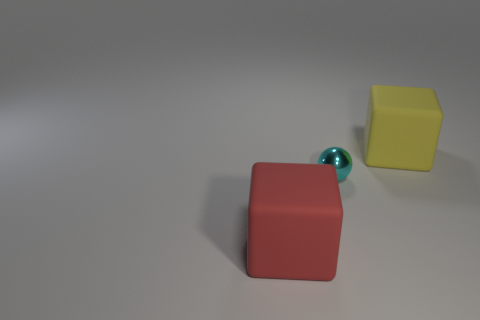Add 1 yellow cubes. How many objects exist? 4 Subtract all spheres. How many objects are left? 2 Add 2 small matte cubes. How many small matte cubes exist? 2 Subtract 0 brown cylinders. How many objects are left? 3 Subtract all yellow rubber cubes. Subtract all red matte blocks. How many objects are left? 1 Add 1 matte things. How many matte things are left? 3 